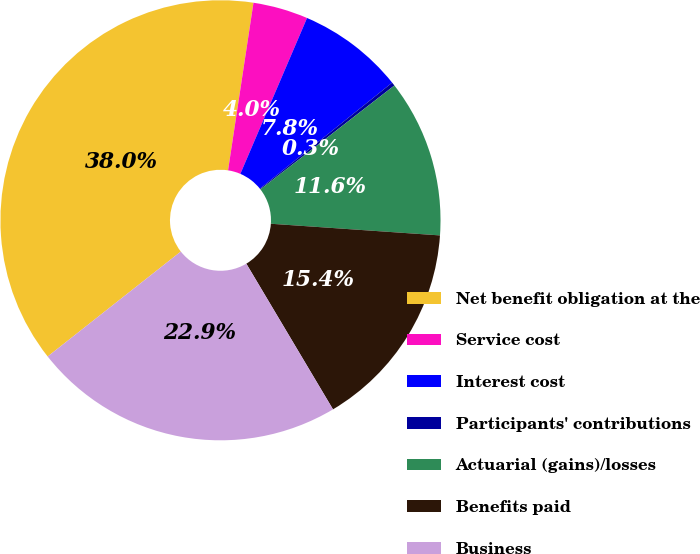Convert chart to OTSL. <chart><loc_0><loc_0><loc_500><loc_500><pie_chart><fcel>Net benefit obligation at the<fcel>Service cost<fcel>Interest cost<fcel>Participants' contributions<fcel>Actuarial (gains)/losses<fcel>Benefits paid<fcel>Business<nl><fcel>38.02%<fcel>4.04%<fcel>7.81%<fcel>0.26%<fcel>11.59%<fcel>15.36%<fcel>22.92%<nl></chart> 